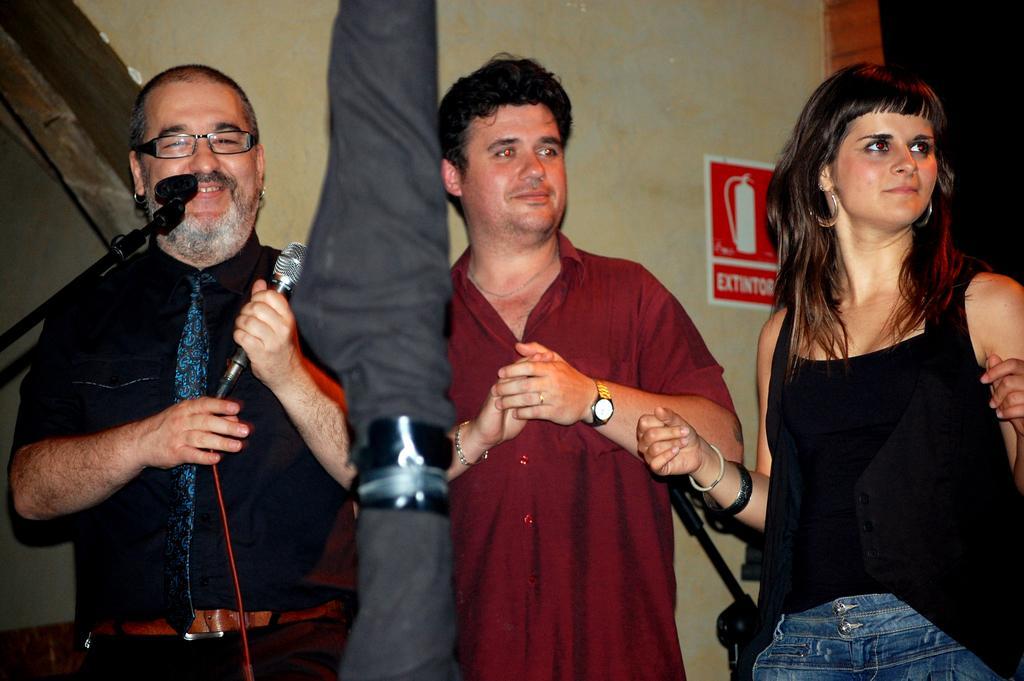In one or two sentences, can you explain what this image depicts? As we can see in the image, there is a wall, poster and three people standing. The man who is standing on the left side is holding mic 